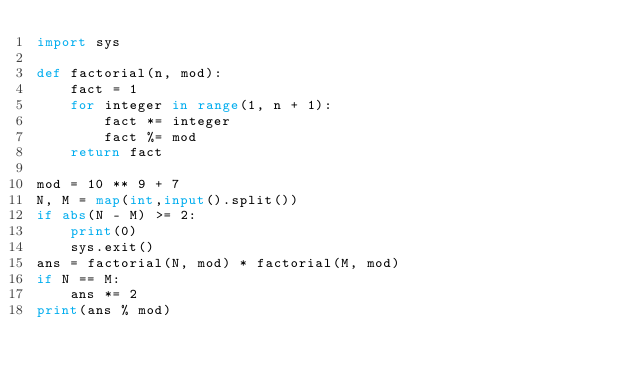<code> <loc_0><loc_0><loc_500><loc_500><_Python_>import sys

def factorial(n, mod):
    fact = 1
    for integer in range(1, n + 1):
        fact *= integer
        fact %= mod
    return fact

mod = 10 ** 9 + 7
N, M = map(int,input().split())
if abs(N - M) >= 2:
    print(0)
    sys.exit()
ans = factorial(N, mod) * factorial(M, mod)
if N == M:
    ans *= 2
print(ans % mod)</code> 